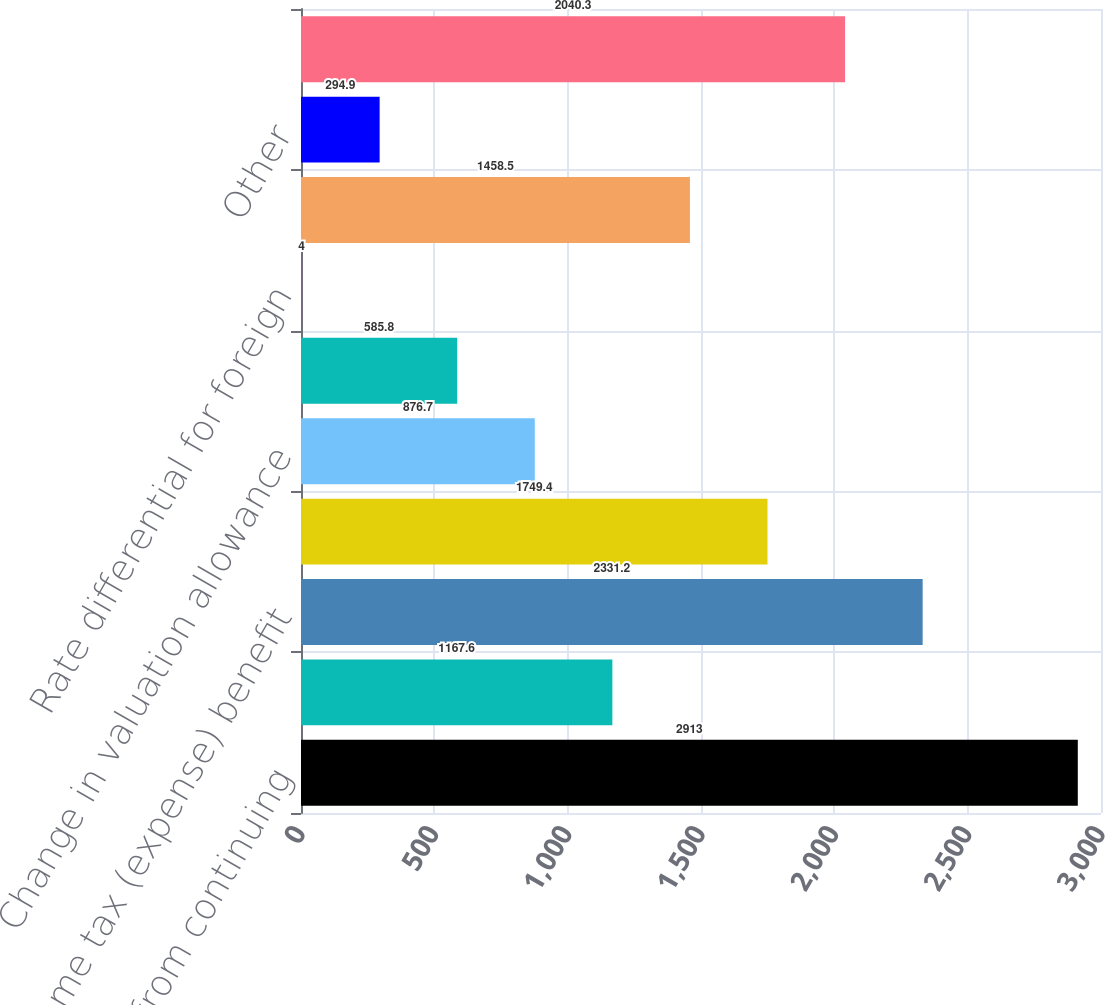<chart> <loc_0><loc_0><loc_500><loc_500><bar_chart><fcel>Income (loss) from continuing<fcel>United States statutory<fcel>Income tax (expense) benefit<fcel>Percentage depletion<fcel>Change in valuation allowance<fcel>US tax effect of<fcel>Rate differential for foreign<fcel>Resolution of prior years'<fcel>Other<fcel>Income tax expense<nl><fcel>2913<fcel>1167.6<fcel>2331.2<fcel>1749.4<fcel>876.7<fcel>585.8<fcel>4<fcel>1458.5<fcel>294.9<fcel>2040.3<nl></chart> 